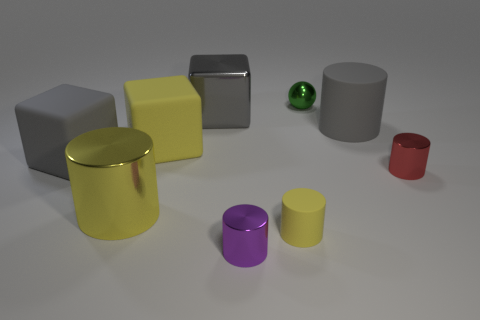Are the green ball that is behind the small yellow cylinder and the small cylinder to the left of the small yellow rubber object made of the same material?
Your response must be concise. Yes. There is a purple object that is the same shape as the yellow metallic object; what is it made of?
Give a very brief answer. Metal. Does the large gray object that is on the right side of the large gray shiny object have the same shape as the metal object that is right of the tiny green metal sphere?
Give a very brief answer. Yes. Is the number of shiny balls to the right of the tiny red metallic object less than the number of large objects that are to the left of the gray shiny thing?
Your answer should be very brief. Yes. What number of other things are there of the same shape as the tiny red thing?
Your answer should be compact. 4. What shape is the small red thing that is made of the same material as the purple thing?
Your response must be concise. Cylinder. What color is the metallic cylinder that is both on the left side of the red object and on the right side of the large gray shiny thing?
Provide a short and direct response. Purple. Do the yellow thing that is in front of the yellow shiny cylinder and the small purple cylinder have the same material?
Provide a succinct answer. No. Is the number of yellow matte cubes behind the tiny green sphere less than the number of green shiny things?
Ensure brevity in your answer.  Yes. Is there a tiny green sphere made of the same material as the purple cylinder?
Provide a short and direct response. Yes. 